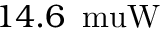<formula> <loc_0><loc_0><loc_500><loc_500>1 4 . 6 { \, \ m u W }</formula> 